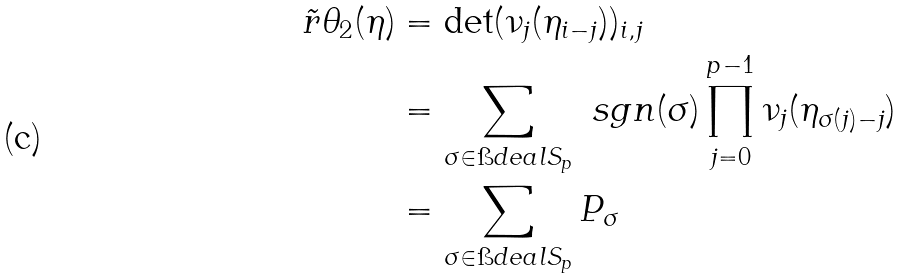<formula> <loc_0><loc_0><loc_500><loc_500>\tilde { r } { \theta } _ { 2 } ( \eta ) & = \det ( \nu _ { j } ( \eta _ { i - j } ) ) _ { i , j } \\ & = \sum _ { \sigma \in \i d e a l { S } _ { p } } \ s g n ( \sigma ) \prod _ { j = 0 } ^ { p - 1 } \nu _ { j } ( \eta _ { \sigma ( j ) - j } ) \\ & = \sum _ { \sigma \in \i d e a l { S } _ { p } } P _ { \sigma }</formula> 